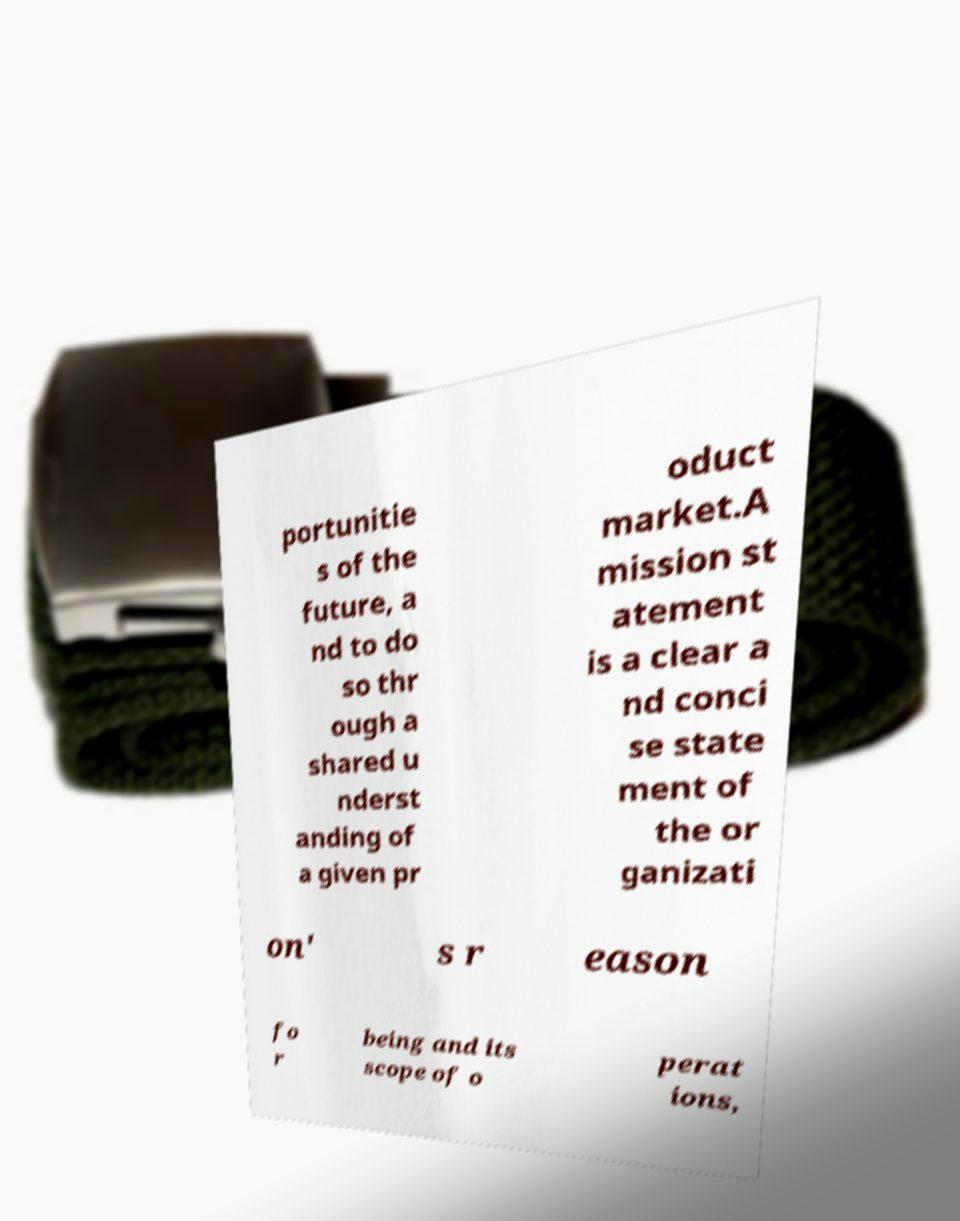There's text embedded in this image that I need extracted. Can you transcribe it verbatim? portunitie s of the future, a nd to do so thr ough a shared u nderst anding of a given pr oduct market.A mission st atement is a clear a nd conci se state ment of the or ganizati on' s r eason fo r being and its scope of o perat ions, 